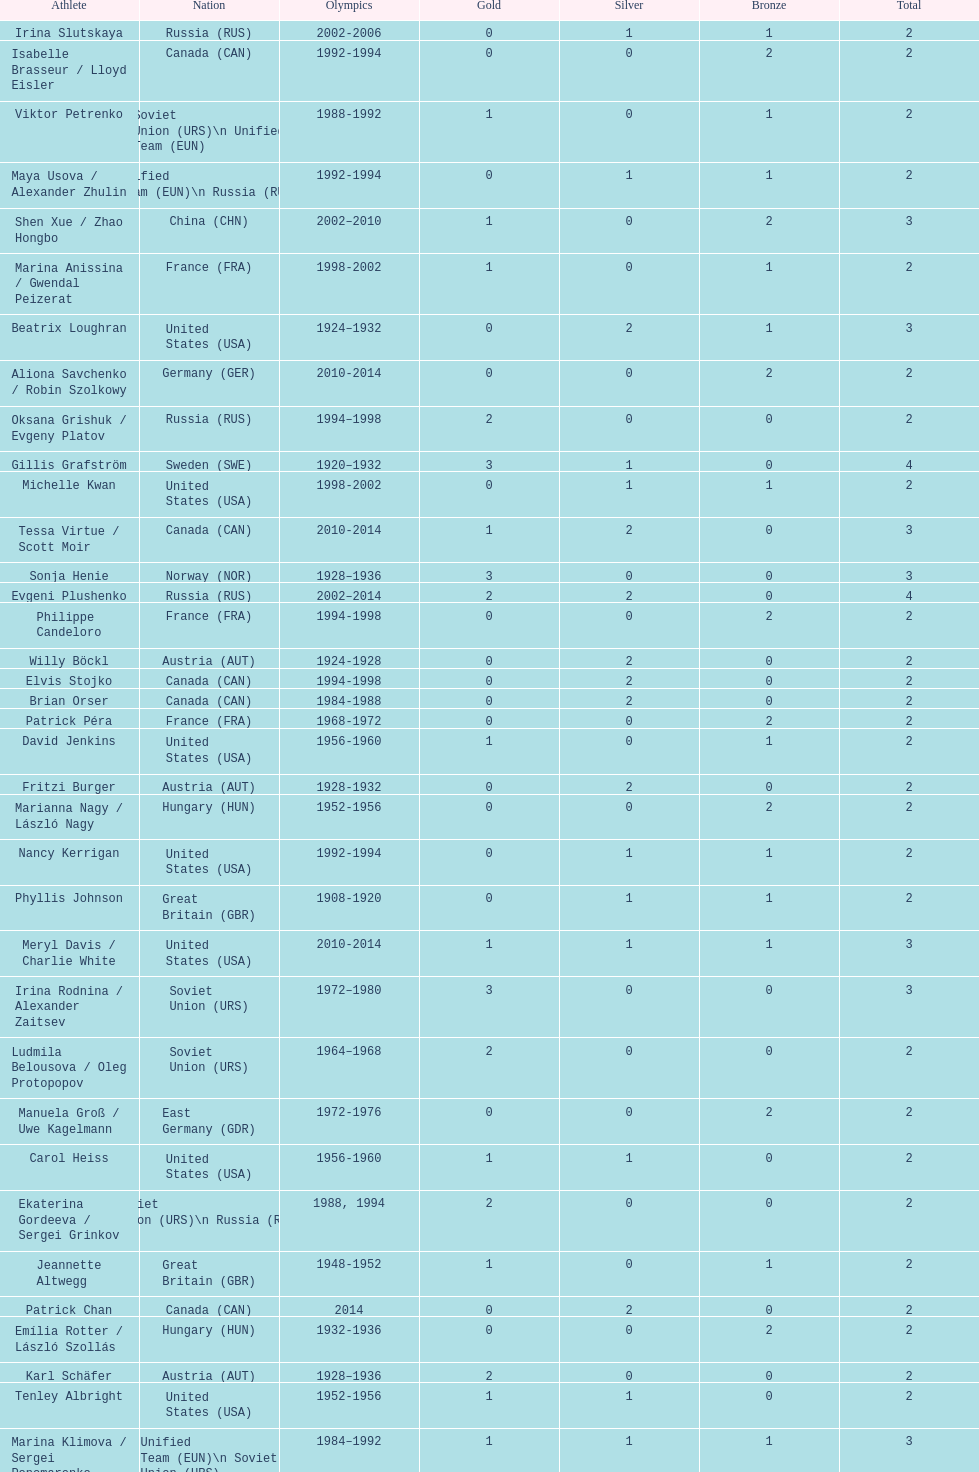What was the greatest number of gold medals won by a single athlete? 3. Give me the full table as a dictionary. {'header': ['Athlete', 'Nation', 'Olympics', 'Gold', 'Silver', 'Bronze', 'Total'], 'rows': [['Irina Slutskaya', 'Russia\xa0(RUS)', '2002-2006', '0', '1', '1', '2'], ['Isabelle Brasseur / Lloyd Eisler', 'Canada\xa0(CAN)', '1992-1994', '0', '0', '2', '2'], ['Viktor Petrenko', 'Soviet Union\xa0(URS)\\n\xa0Unified Team\xa0(EUN)', '1988-1992', '1', '0', '1', '2'], ['Maya Usova / Alexander Zhulin', 'Unified Team\xa0(EUN)\\n\xa0Russia\xa0(RUS)', '1992-1994', '0', '1', '1', '2'], ['Shen Xue / Zhao Hongbo', 'China\xa0(CHN)', '2002–2010', '1', '0', '2', '3'], ['Marina Anissina / Gwendal Peizerat', 'France\xa0(FRA)', '1998-2002', '1', '0', '1', '2'], ['Beatrix Loughran', 'United States\xa0(USA)', '1924–1932', '0', '2', '1', '3'], ['Aliona Savchenko / Robin Szolkowy', 'Germany\xa0(GER)', '2010-2014', '0', '0', '2', '2'], ['Oksana Grishuk / Evgeny Platov', 'Russia\xa0(RUS)', '1994–1998', '2', '0', '0', '2'], ['Gillis Grafström', 'Sweden\xa0(SWE)', '1920–1932', '3', '1', '0', '4'], ['Michelle Kwan', 'United States\xa0(USA)', '1998-2002', '0', '1', '1', '2'], ['Tessa Virtue / Scott Moir', 'Canada\xa0(CAN)', '2010-2014', '1', '2', '0', '3'], ['Sonja Henie', 'Norway\xa0(NOR)', '1928–1936', '3', '0', '0', '3'], ['Evgeni Plushenko', 'Russia\xa0(RUS)', '2002–2014', '2', '2', '0', '4'], ['Philippe Candeloro', 'France\xa0(FRA)', '1994-1998', '0', '0', '2', '2'], ['Willy Böckl', 'Austria\xa0(AUT)', '1924-1928', '0', '2', '0', '2'], ['Elvis Stojko', 'Canada\xa0(CAN)', '1994-1998', '0', '2', '0', '2'], ['Brian Orser', 'Canada\xa0(CAN)', '1984-1988', '0', '2', '0', '2'], ['Patrick Péra', 'France\xa0(FRA)', '1968-1972', '0', '0', '2', '2'], ['David Jenkins', 'United States\xa0(USA)', '1956-1960', '1', '0', '1', '2'], ['Fritzi Burger', 'Austria\xa0(AUT)', '1928-1932', '0', '2', '0', '2'], ['Marianna Nagy / László Nagy', 'Hungary\xa0(HUN)', '1952-1956', '0', '0', '2', '2'], ['Nancy Kerrigan', 'United States\xa0(USA)', '1992-1994', '0', '1', '1', '2'], ['Phyllis Johnson', 'Great Britain\xa0(GBR)', '1908-1920', '0', '1', '1', '2'], ['Meryl Davis / Charlie White', 'United States\xa0(USA)', '2010-2014', '1', '1', '1', '3'], ['Irina Rodnina / Alexander Zaitsev', 'Soviet Union\xa0(URS)', '1972–1980', '3', '0', '0', '3'], ['Ludmila Belousova / Oleg Protopopov', 'Soviet Union\xa0(URS)', '1964–1968', '2', '0', '0', '2'], ['Manuela Groß / Uwe Kagelmann', 'East Germany\xa0(GDR)', '1972-1976', '0', '0', '2', '2'], ['Carol Heiss', 'United States\xa0(USA)', '1956-1960', '1', '1', '0', '2'], ['Ekaterina Gordeeva / Sergei Grinkov', 'Soviet Union\xa0(URS)\\n\xa0Russia\xa0(RUS)', '1988, 1994', '2', '0', '0', '2'], ['Jeannette Altwegg', 'Great Britain\xa0(GBR)', '1948-1952', '1', '0', '1', '2'], ['Patrick Chan', 'Canada\xa0(CAN)', '2014', '0', '2', '0', '2'], ['Emília Rotter / László Szollás', 'Hungary\xa0(HUN)', '1932-1936', '0', '0', '2', '2'], ['Karl Schäfer', 'Austria\xa0(AUT)', '1928–1936', '2', '0', '0', '2'], ['Tenley Albright', 'United States\xa0(USA)', '1952-1956', '1', '1', '0', '2'], ['Marina Klimova / Sergei Ponomarenko', 'Unified Team\xa0(EUN)\\n\xa0Soviet Union\xa0(URS)', '1984–1992', '1', '1', '1', '3'], ['Kim Yu-na', 'South Korea\xa0(KOR)', '2010–2014', '1', '1', '0', '2'], ['Chen Lu', 'China\xa0(CHN)', '1994-1998', '0', '0', '2', '2'], ['Tatiana Volosozhar / Maxim Trankov', 'Russia\xa0(RUS)', '2014', '2', '0', '0', '2'], ['Elena Berezhnaya / Anton Sikharulidze', 'Russia\xa0(RUS)', '1998-2002', '1', '1', '0', '2'], ['Dick Button', 'United States\xa0(USA)', '1948–1952', '2', '0', '0', '2'], ['Katarina Witt', 'East Germany\xa0(GDR)', '1984–1988', '2', '0', '0', '2'], ['Artur Dmitriev / Natalia Mishkutenok', 'Unified Team\xa0(EUN)\\n\xa0Russia\xa0(RUS)', '1992–1998', '2', '1', '0', '3'], ['Ludowika Jakobsson / Walter Jakobsson', 'Finland\xa0(FIN)', '1920-1924', '1', '1', '0', '2'], ['Andrée Brunet / Pierre Brunet', 'France\xa0(FRA)', '1924–1932', '2', '0', '1', '3'], ['Marika Kilius / Hans-Jürgen Bäumler', 'Unified Team of Germany\xa0(EUA)', '1960-1964', '0', '2', '0', '2'], ['Sjoukje Dijkstra', 'Netherlands\xa0(NED)', '1960-1964', '1', '1', '0', '2']]} 